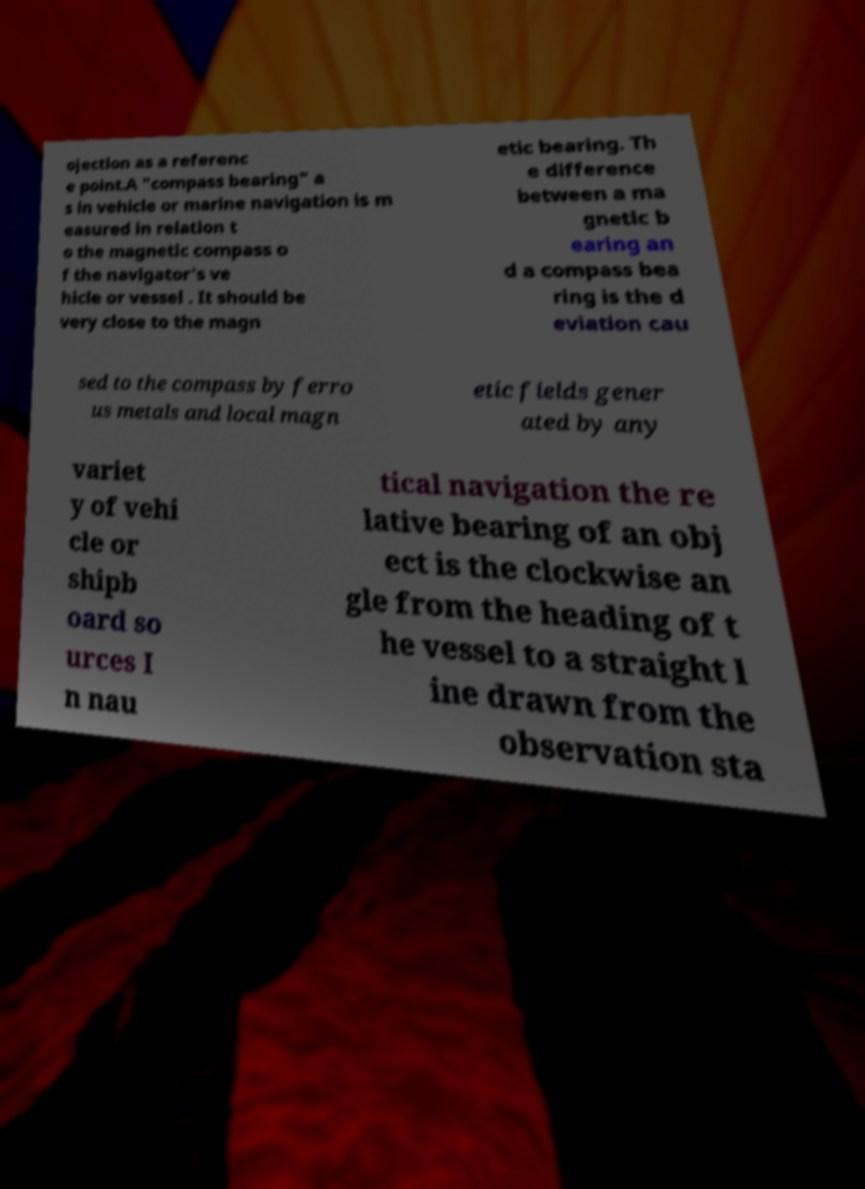What messages or text are displayed in this image? I need them in a readable, typed format. ojection as a referenc e point.A "compass bearing" a s in vehicle or marine navigation is m easured in relation t o the magnetic compass o f the navigator's ve hicle or vessel . It should be very close to the magn etic bearing. Th e difference between a ma gnetic b earing an d a compass bea ring is the d eviation cau sed to the compass by ferro us metals and local magn etic fields gener ated by any variet y of vehi cle or shipb oard so urces I n nau tical navigation the re lative bearing of an obj ect is the clockwise an gle from the heading of t he vessel to a straight l ine drawn from the observation sta 